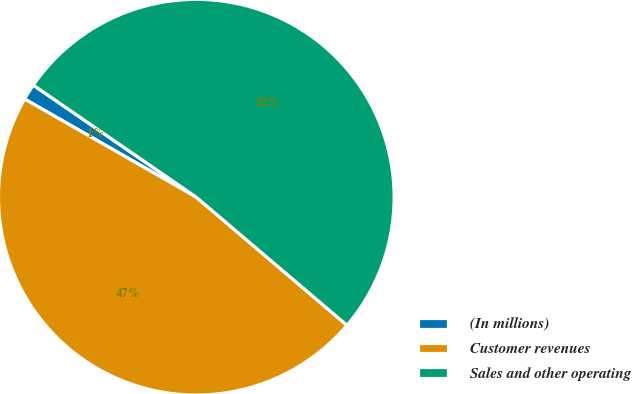Convert chart. <chart><loc_0><loc_0><loc_500><loc_500><pie_chart><fcel>(In millions)<fcel>Customer revenues<fcel>Sales and other operating<nl><fcel>1.32%<fcel>47.06%<fcel>51.63%<nl></chart> 